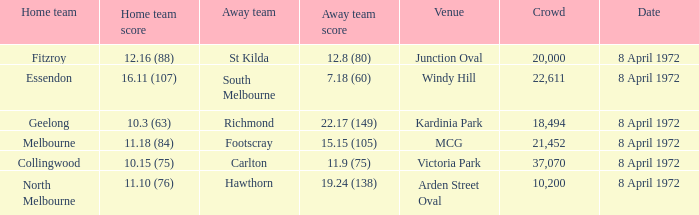Which Home team score has a Home team of geelong? 10.3 (63). 